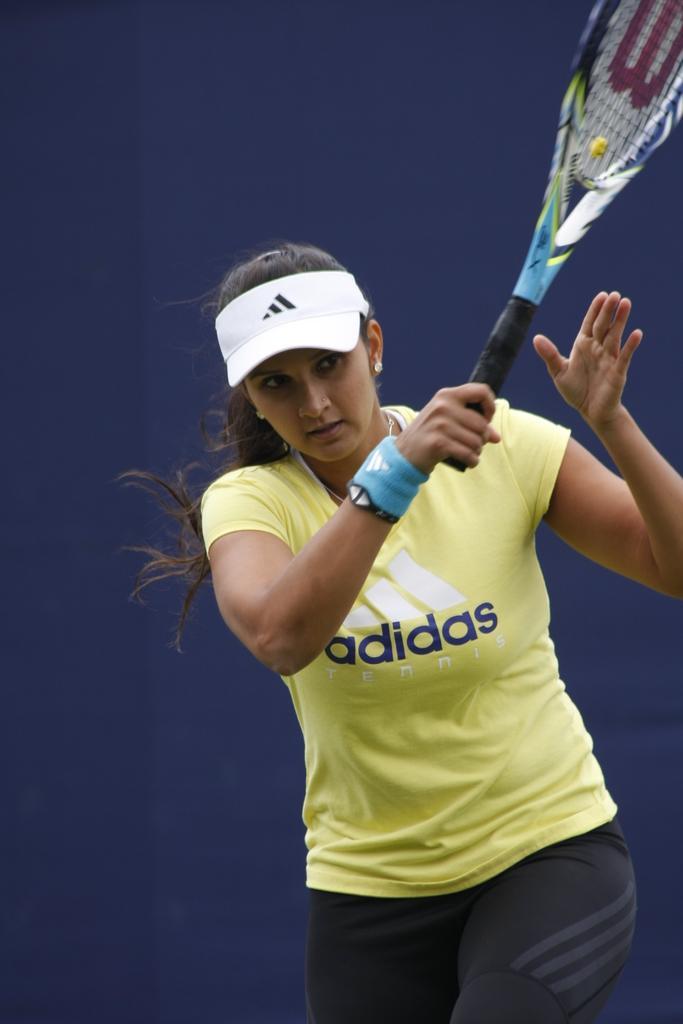How would you summarize this image in a sentence or two? This is a picture of a woman, the woman is in yellow t shirt. The t shirt brand is Adidas. The woman is holding a tennis racket. Background of the woman is a blue color wall. 